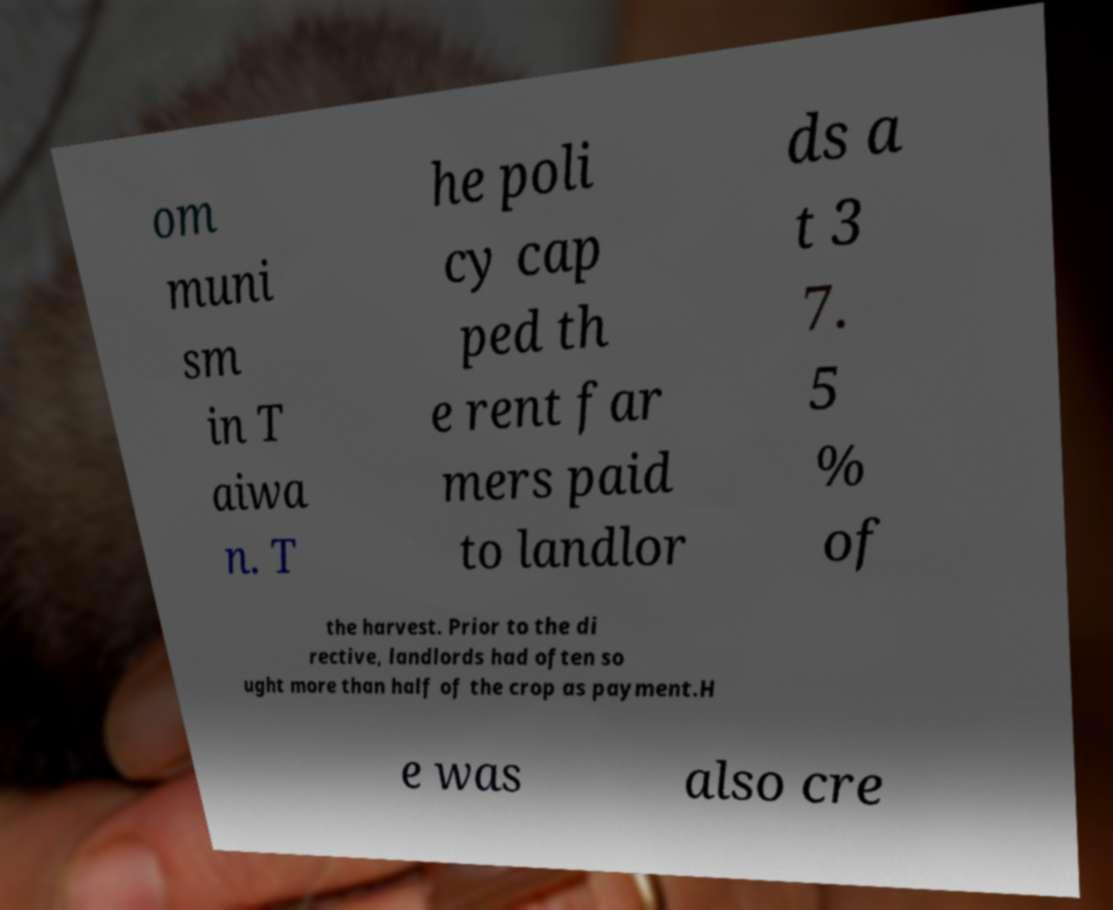Can you read and provide the text displayed in the image?This photo seems to have some interesting text. Can you extract and type it out for me? om muni sm in T aiwa n. T he poli cy cap ped th e rent far mers paid to landlor ds a t 3 7. 5 % of the harvest. Prior to the di rective, landlords had often so ught more than half of the crop as payment.H e was also cre 